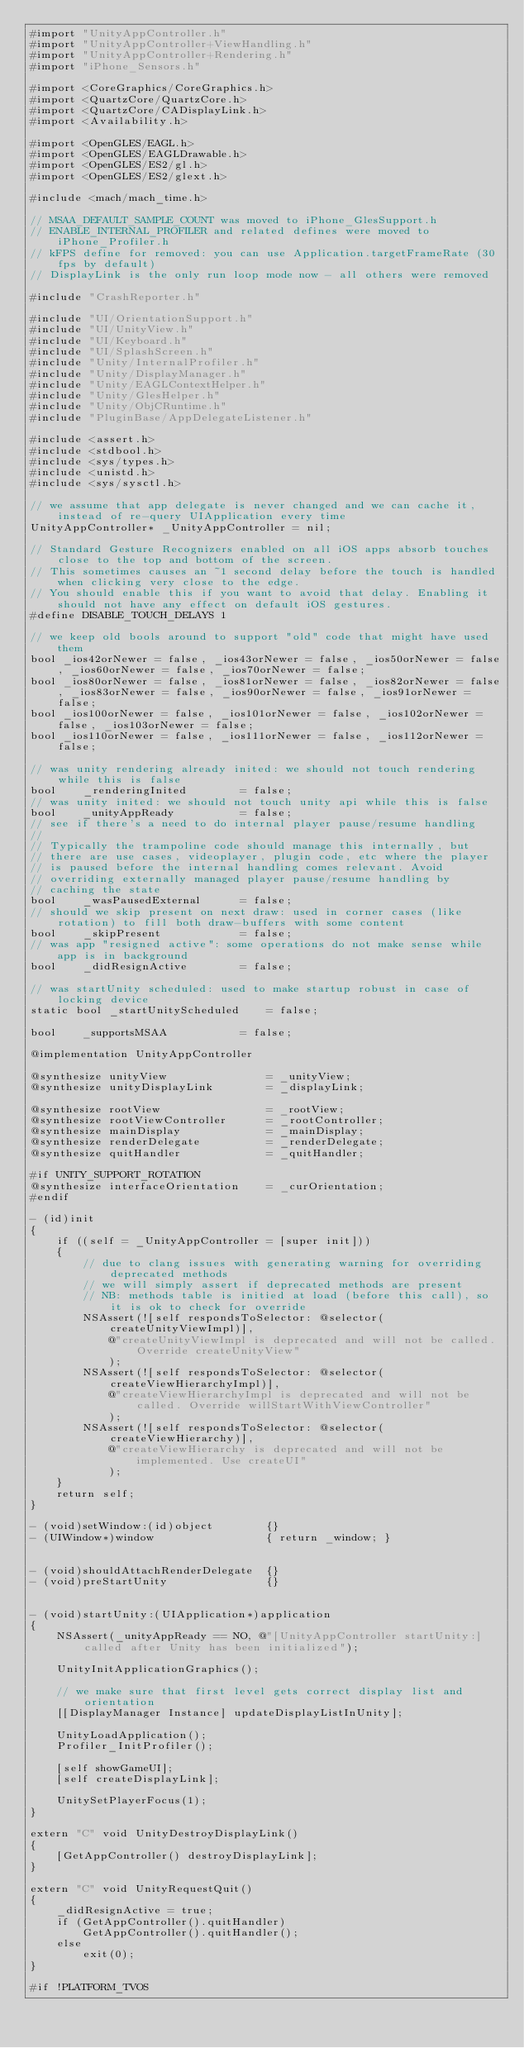<code> <loc_0><loc_0><loc_500><loc_500><_ObjectiveC_>#import "UnityAppController.h"
#import "UnityAppController+ViewHandling.h"
#import "UnityAppController+Rendering.h"
#import "iPhone_Sensors.h"

#import <CoreGraphics/CoreGraphics.h>
#import <QuartzCore/QuartzCore.h>
#import <QuartzCore/CADisplayLink.h>
#import <Availability.h>

#import <OpenGLES/EAGL.h>
#import <OpenGLES/EAGLDrawable.h>
#import <OpenGLES/ES2/gl.h>
#import <OpenGLES/ES2/glext.h>

#include <mach/mach_time.h>

// MSAA_DEFAULT_SAMPLE_COUNT was moved to iPhone_GlesSupport.h
// ENABLE_INTERNAL_PROFILER and related defines were moved to iPhone_Profiler.h
// kFPS define for removed: you can use Application.targetFrameRate (30 fps by default)
// DisplayLink is the only run loop mode now - all others were removed

#include "CrashReporter.h"

#include "UI/OrientationSupport.h"
#include "UI/UnityView.h"
#include "UI/Keyboard.h"
#include "UI/SplashScreen.h"
#include "Unity/InternalProfiler.h"
#include "Unity/DisplayManager.h"
#include "Unity/EAGLContextHelper.h"
#include "Unity/GlesHelper.h"
#include "Unity/ObjCRuntime.h"
#include "PluginBase/AppDelegateListener.h"

#include <assert.h>
#include <stdbool.h>
#include <sys/types.h>
#include <unistd.h>
#include <sys/sysctl.h>

// we assume that app delegate is never changed and we can cache it, instead of re-query UIApplication every time
UnityAppController* _UnityAppController = nil;

// Standard Gesture Recognizers enabled on all iOS apps absorb touches close to the top and bottom of the screen.
// This sometimes causes an ~1 second delay before the touch is handled when clicking very close to the edge.
// You should enable this if you want to avoid that delay. Enabling it should not have any effect on default iOS gestures.
#define DISABLE_TOUCH_DELAYS 1

// we keep old bools around to support "old" code that might have used them
bool _ios42orNewer = false, _ios43orNewer = false, _ios50orNewer = false, _ios60orNewer = false, _ios70orNewer = false;
bool _ios80orNewer = false, _ios81orNewer = false, _ios82orNewer = false, _ios83orNewer = false, _ios90orNewer = false, _ios91orNewer = false;
bool _ios100orNewer = false, _ios101orNewer = false, _ios102orNewer = false, _ios103orNewer = false;
bool _ios110orNewer = false, _ios111orNewer = false, _ios112orNewer = false;

// was unity rendering already inited: we should not touch rendering while this is false
bool    _renderingInited        = false;
// was unity inited: we should not touch unity api while this is false
bool    _unityAppReady          = false;
// see if there's a need to do internal player pause/resume handling
//
// Typically the trampoline code should manage this internally, but
// there are use cases, videoplayer, plugin code, etc where the player
// is paused before the internal handling comes relevant. Avoid
// overriding externally managed player pause/resume handling by
// caching the state
bool    _wasPausedExternal      = false;
// should we skip present on next draw: used in corner cases (like rotation) to fill both draw-buffers with some content
bool    _skipPresent            = false;
// was app "resigned active": some operations do not make sense while app is in background
bool    _didResignActive        = false;

// was startUnity scheduled: used to make startup robust in case of locking device
static bool _startUnityScheduled    = false;

bool    _supportsMSAA           = false;

@implementation UnityAppController

@synthesize unityView               = _unityView;
@synthesize unityDisplayLink        = _displayLink;

@synthesize rootView                = _rootView;
@synthesize rootViewController      = _rootController;
@synthesize mainDisplay             = _mainDisplay;
@synthesize renderDelegate          = _renderDelegate;
@synthesize quitHandler             = _quitHandler;

#if UNITY_SUPPORT_ROTATION
@synthesize interfaceOrientation    = _curOrientation;
#endif

- (id)init
{
    if ((self = _UnityAppController = [super init]))
    {
        // due to clang issues with generating warning for overriding deprecated methods
        // we will simply assert if deprecated methods are present
        // NB: methods table is initied at load (before this call), so it is ok to check for override
        NSAssert(![self respondsToSelector: @selector(createUnityViewImpl)],
            @"createUnityViewImpl is deprecated and will not be called. Override createUnityView"
            );
        NSAssert(![self respondsToSelector: @selector(createViewHierarchyImpl)],
            @"createViewHierarchyImpl is deprecated and will not be called. Override willStartWithViewController"
            );
        NSAssert(![self respondsToSelector: @selector(createViewHierarchy)],
            @"createViewHierarchy is deprecated and will not be implemented. Use createUI"
            );
    }
    return self;
}

- (void)setWindow:(id)object        {}
- (UIWindow*)window                 { return _window; }


- (void)shouldAttachRenderDelegate  {}
- (void)preStartUnity               {}


- (void)startUnity:(UIApplication*)application
{
    NSAssert(_unityAppReady == NO, @"[UnityAppController startUnity:] called after Unity has been initialized");

    UnityInitApplicationGraphics();

    // we make sure that first level gets correct display list and orientation
    [[DisplayManager Instance] updateDisplayListInUnity];

    UnityLoadApplication();
    Profiler_InitProfiler();

    [self showGameUI];
    [self createDisplayLink];

    UnitySetPlayerFocus(1);
}

extern "C" void UnityDestroyDisplayLink()
{
    [GetAppController() destroyDisplayLink];
}

extern "C" void UnityRequestQuit()
{
    _didResignActive = true;
    if (GetAppController().quitHandler)
        GetAppController().quitHandler();
    else
        exit(0);
}

#if !PLATFORM_TVOS</code> 